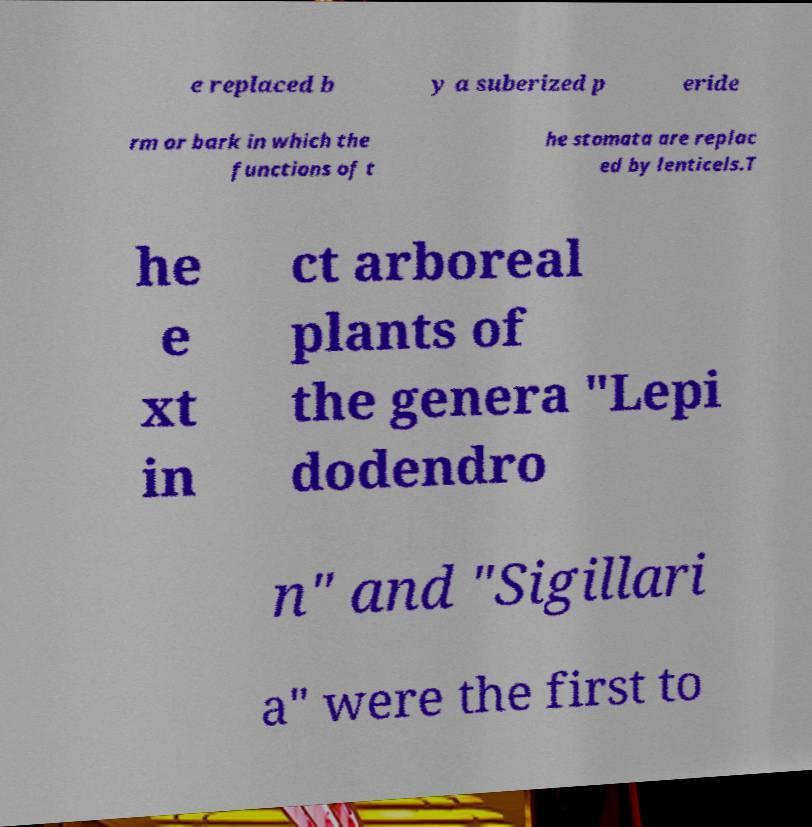Please identify and transcribe the text found in this image. e replaced b y a suberized p eride rm or bark in which the functions of t he stomata are replac ed by lenticels.T he e xt in ct arboreal plants of the genera "Lepi dodendro n" and "Sigillari a" were the first to 